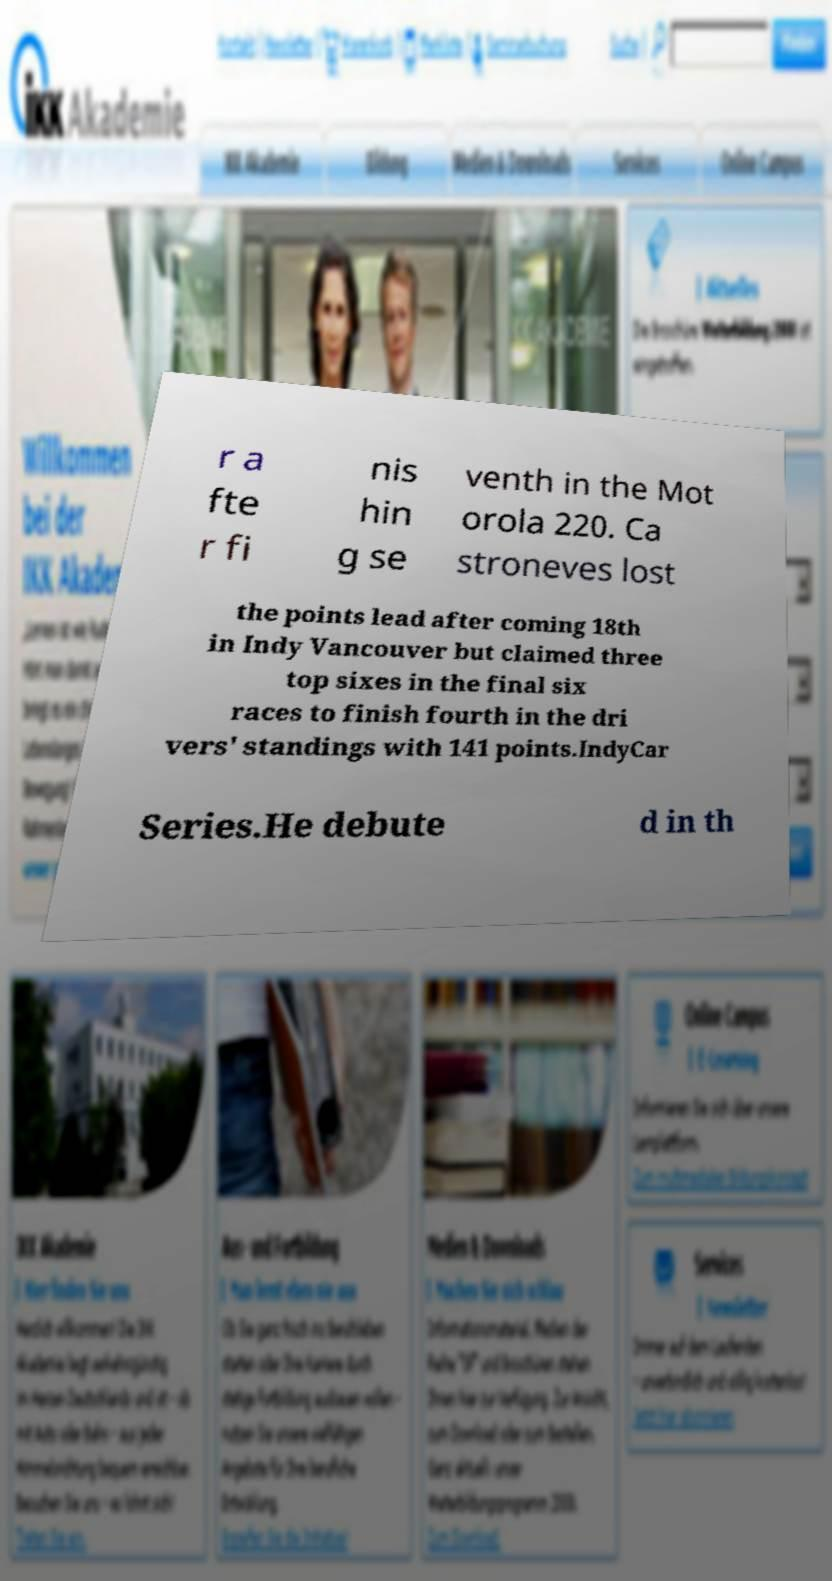Please read and relay the text visible in this image. What does it say? r a fte r fi nis hin g se venth in the Mot orola 220. Ca stroneves lost the points lead after coming 18th in Indy Vancouver but claimed three top sixes in the final six races to finish fourth in the dri vers' standings with 141 points.IndyCar Series.He debute d in th 